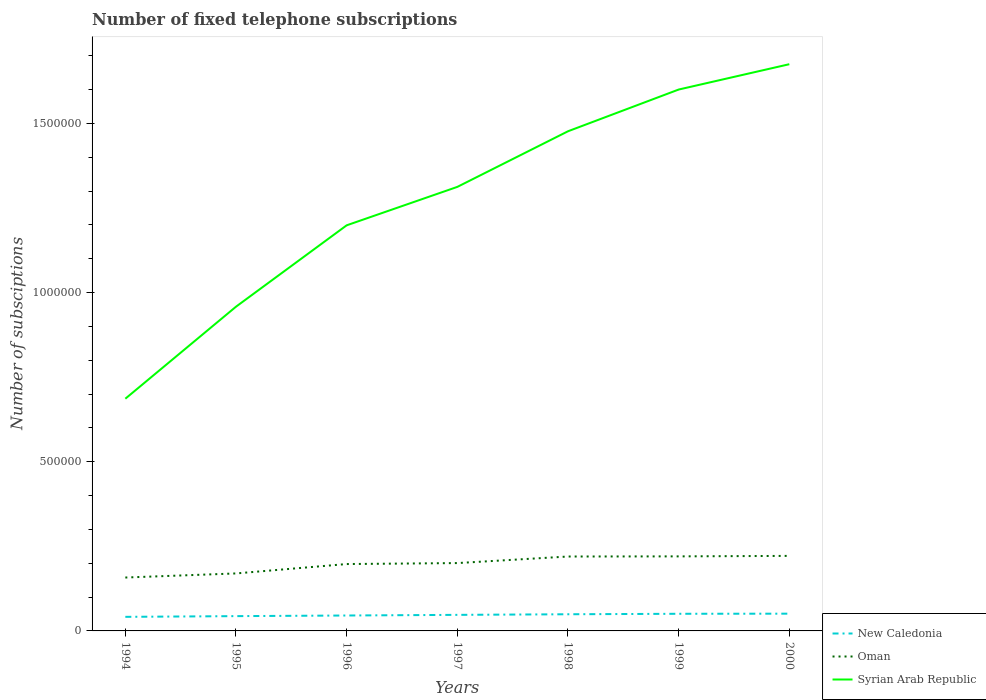How many different coloured lines are there?
Provide a succinct answer. 3. Across all years, what is the maximum number of fixed telephone subscriptions in New Caledonia?
Your answer should be compact. 4.16e+04. In which year was the number of fixed telephone subscriptions in Oman maximum?
Give a very brief answer. 1994. What is the total number of fixed telephone subscriptions in Oman in the graph?
Make the answer very short. -1434. What is the difference between the highest and the second highest number of fixed telephone subscriptions in New Caledonia?
Provide a short and direct response. 9400. Is the number of fixed telephone subscriptions in New Caledonia strictly greater than the number of fixed telephone subscriptions in Syrian Arab Republic over the years?
Provide a succinct answer. Yes. How many lines are there?
Your response must be concise. 3. How many years are there in the graph?
Make the answer very short. 7. What is the difference between two consecutive major ticks on the Y-axis?
Make the answer very short. 5.00e+05. Where does the legend appear in the graph?
Your answer should be very brief. Bottom right. How many legend labels are there?
Your response must be concise. 3. How are the legend labels stacked?
Your response must be concise. Vertical. What is the title of the graph?
Your response must be concise. Number of fixed telephone subscriptions. What is the label or title of the Y-axis?
Provide a short and direct response. Number of subsciptions. What is the Number of subsciptions of New Caledonia in 1994?
Offer a terse response. 4.16e+04. What is the Number of subsciptions of Oman in 1994?
Offer a terse response. 1.58e+05. What is the Number of subsciptions in Syrian Arab Republic in 1994?
Provide a succinct answer. 6.86e+05. What is the Number of subsciptions in New Caledonia in 1995?
Ensure brevity in your answer.  4.37e+04. What is the Number of subsciptions of Oman in 1995?
Your answer should be very brief. 1.70e+05. What is the Number of subsciptions of Syrian Arab Republic in 1995?
Your answer should be compact. 9.58e+05. What is the Number of subsciptions of New Caledonia in 1996?
Your answer should be very brief. 4.56e+04. What is the Number of subsciptions of Oman in 1996?
Your answer should be compact. 1.98e+05. What is the Number of subsciptions of Syrian Arab Republic in 1996?
Keep it short and to the point. 1.20e+06. What is the Number of subsciptions in New Caledonia in 1997?
Give a very brief answer. 4.75e+04. What is the Number of subsciptions in Oman in 1997?
Provide a succinct answer. 2.01e+05. What is the Number of subsciptions in Syrian Arab Republic in 1997?
Ensure brevity in your answer.  1.31e+06. What is the Number of subsciptions of New Caledonia in 1998?
Provide a short and direct response. 4.93e+04. What is the Number of subsciptions in Oman in 1998?
Give a very brief answer. 2.20e+05. What is the Number of subsciptions in Syrian Arab Republic in 1998?
Keep it short and to the point. 1.48e+06. What is the Number of subsciptions in New Caledonia in 1999?
Provide a succinct answer. 5.07e+04. What is the Number of subsciptions in Oman in 1999?
Provide a succinct answer. 2.20e+05. What is the Number of subsciptions of Syrian Arab Republic in 1999?
Make the answer very short. 1.60e+06. What is the Number of subsciptions of New Caledonia in 2000?
Your answer should be very brief. 5.10e+04. What is the Number of subsciptions in Oman in 2000?
Your response must be concise. 2.22e+05. What is the Number of subsciptions in Syrian Arab Republic in 2000?
Provide a short and direct response. 1.68e+06. Across all years, what is the maximum Number of subsciptions of New Caledonia?
Provide a short and direct response. 5.10e+04. Across all years, what is the maximum Number of subsciptions in Oman?
Provide a succinct answer. 2.22e+05. Across all years, what is the maximum Number of subsciptions of Syrian Arab Republic?
Make the answer very short. 1.68e+06. Across all years, what is the minimum Number of subsciptions of New Caledonia?
Offer a terse response. 4.16e+04. Across all years, what is the minimum Number of subsciptions of Oman?
Your answer should be compact. 1.58e+05. Across all years, what is the minimum Number of subsciptions in Syrian Arab Republic?
Give a very brief answer. 6.86e+05. What is the total Number of subsciptions in New Caledonia in the graph?
Give a very brief answer. 3.29e+05. What is the total Number of subsciptions in Oman in the graph?
Offer a terse response. 1.39e+06. What is the total Number of subsciptions in Syrian Arab Republic in the graph?
Provide a succinct answer. 8.91e+06. What is the difference between the Number of subsciptions of New Caledonia in 1994 and that in 1995?
Offer a very short reply. -2120. What is the difference between the Number of subsciptions in Oman in 1994 and that in 1995?
Your response must be concise. -1.21e+04. What is the difference between the Number of subsciptions in Syrian Arab Republic in 1994 and that in 1995?
Provide a succinct answer. -2.72e+05. What is the difference between the Number of subsciptions in New Caledonia in 1994 and that in 1996?
Keep it short and to the point. -3969. What is the difference between the Number of subsciptions of Oman in 1994 and that in 1996?
Offer a very short reply. -3.98e+04. What is the difference between the Number of subsciptions of Syrian Arab Republic in 1994 and that in 1996?
Offer a terse response. -5.13e+05. What is the difference between the Number of subsciptions of New Caledonia in 1994 and that in 1997?
Provide a short and direct response. -5874. What is the difference between the Number of subsciptions in Oman in 1994 and that in 1997?
Give a very brief answer. -4.27e+04. What is the difference between the Number of subsciptions in Syrian Arab Republic in 1994 and that in 1997?
Give a very brief answer. -6.26e+05. What is the difference between the Number of subsciptions of New Caledonia in 1994 and that in 1998?
Your answer should be compact. -7654. What is the difference between the Number of subsciptions in Oman in 1994 and that in 1998?
Offer a very short reply. -6.21e+04. What is the difference between the Number of subsciptions of Syrian Arab Republic in 1994 and that in 1998?
Your answer should be compact. -7.91e+05. What is the difference between the Number of subsciptions in New Caledonia in 1994 and that in 1999?
Your answer should be very brief. -9047. What is the difference between the Number of subsciptions of Oman in 1994 and that in 1999?
Your answer should be very brief. -6.25e+04. What is the difference between the Number of subsciptions of Syrian Arab Republic in 1994 and that in 1999?
Make the answer very short. -9.14e+05. What is the difference between the Number of subsciptions of New Caledonia in 1994 and that in 2000?
Your answer should be compact. -9400. What is the difference between the Number of subsciptions of Oman in 1994 and that in 2000?
Provide a succinct answer. -6.40e+04. What is the difference between the Number of subsciptions in Syrian Arab Republic in 1994 and that in 2000?
Your answer should be compact. -9.89e+05. What is the difference between the Number of subsciptions in New Caledonia in 1995 and that in 1996?
Make the answer very short. -1849. What is the difference between the Number of subsciptions in Oman in 1995 and that in 1996?
Give a very brief answer. -2.77e+04. What is the difference between the Number of subsciptions in Syrian Arab Republic in 1995 and that in 1996?
Keep it short and to the point. -2.41e+05. What is the difference between the Number of subsciptions in New Caledonia in 1995 and that in 1997?
Give a very brief answer. -3754. What is the difference between the Number of subsciptions of Oman in 1995 and that in 1997?
Your response must be concise. -3.06e+04. What is the difference between the Number of subsciptions in Syrian Arab Republic in 1995 and that in 1997?
Offer a very short reply. -3.54e+05. What is the difference between the Number of subsciptions in New Caledonia in 1995 and that in 1998?
Offer a terse response. -5534. What is the difference between the Number of subsciptions of Oman in 1995 and that in 1998?
Keep it short and to the point. -5.00e+04. What is the difference between the Number of subsciptions of Syrian Arab Republic in 1995 and that in 1998?
Give a very brief answer. -5.19e+05. What is the difference between the Number of subsciptions in New Caledonia in 1995 and that in 1999?
Your answer should be very brief. -6927. What is the difference between the Number of subsciptions in Oman in 1995 and that in 1999?
Your answer should be very brief. -5.04e+04. What is the difference between the Number of subsciptions of Syrian Arab Republic in 1995 and that in 1999?
Provide a short and direct response. -6.42e+05. What is the difference between the Number of subsciptions in New Caledonia in 1995 and that in 2000?
Keep it short and to the point. -7280. What is the difference between the Number of subsciptions in Oman in 1995 and that in 2000?
Offer a very short reply. -5.19e+04. What is the difference between the Number of subsciptions of Syrian Arab Republic in 1995 and that in 2000?
Your answer should be very brief. -7.17e+05. What is the difference between the Number of subsciptions in New Caledonia in 1996 and that in 1997?
Ensure brevity in your answer.  -1905. What is the difference between the Number of subsciptions in Oman in 1996 and that in 1997?
Provide a short and direct response. -2870. What is the difference between the Number of subsciptions of Syrian Arab Republic in 1996 and that in 1997?
Your answer should be very brief. -1.14e+05. What is the difference between the Number of subsciptions of New Caledonia in 1996 and that in 1998?
Your answer should be compact. -3685. What is the difference between the Number of subsciptions of Oman in 1996 and that in 1998?
Provide a succinct answer. -2.23e+04. What is the difference between the Number of subsciptions of Syrian Arab Republic in 1996 and that in 1998?
Provide a short and direct response. -2.78e+05. What is the difference between the Number of subsciptions of New Caledonia in 1996 and that in 1999?
Ensure brevity in your answer.  -5078. What is the difference between the Number of subsciptions in Oman in 1996 and that in 1999?
Give a very brief answer. -2.27e+04. What is the difference between the Number of subsciptions of Syrian Arab Republic in 1996 and that in 1999?
Offer a terse response. -4.01e+05. What is the difference between the Number of subsciptions of New Caledonia in 1996 and that in 2000?
Offer a very short reply. -5431. What is the difference between the Number of subsciptions of Oman in 1996 and that in 2000?
Ensure brevity in your answer.  -2.41e+04. What is the difference between the Number of subsciptions in Syrian Arab Republic in 1996 and that in 2000?
Offer a terse response. -4.76e+05. What is the difference between the Number of subsciptions of New Caledonia in 1997 and that in 1998?
Provide a short and direct response. -1780. What is the difference between the Number of subsciptions of Oman in 1997 and that in 1998?
Ensure brevity in your answer.  -1.94e+04. What is the difference between the Number of subsciptions of Syrian Arab Republic in 1997 and that in 1998?
Your answer should be very brief. -1.64e+05. What is the difference between the Number of subsciptions of New Caledonia in 1997 and that in 1999?
Provide a short and direct response. -3173. What is the difference between the Number of subsciptions of Oman in 1997 and that in 1999?
Make the answer very short. -1.98e+04. What is the difference between the Number of subsciptions of Syrian Arab Republic in 1997 and that in 1999?
Your answer should be compact. -2.88e+05. What is the difference between the Number of subsciptions in New Caledonia in 1997 and that in 2000?
Provide a succinct answer. -3526. What is the difference between the Number of subsciptions in Oman in 1997 and that in 2000?
Give a very brief answer. -2.12e+04. What is the difference between the Number of subsciptions of Syrian Arab Republic in 1997 and that in 2000?
Your answer should be compact. -3.63e+05. What is the difference between the Number of subsciptions of New Caledonia in 1998 and that in 1999?
Offer a very short reply. -1393. What is the difference between the Number of subsciptions in Oman in 1998 and that in 1999?
Your answer should be very brief. -417. What is the difference between the Number of subsciptions in Syrian Arab Republic in 1998 and that in 1999?
Your answer should be very brief. -1.23e+05. What is the difference between the Number of subsciptions of New Caledonia in 1998 and that in 2000?
Provide a succinct answer. -1746. What is the difference between the Number of subsciptions of Oman in 1998 and that in 2000?
Give a very brief answer. -1851. What is the difference between the Number of subsciptions in Syrian Arab Republic in 1998 and that in 2000?
Keep it short and to the point. -1.98e+05. What is the difference between the Number of subsciptions of New Caledonia in 1999 and that in 2000?
Your answer should be very brief. -353. What is the difference between the Number of subsciptions of Oman in 1999 and that in 2000?
Offer a terse response. -1434. What is the difference between the Number of subsciptions in Syrian Arab Republic in 1999 and that in 2000?
Your answer should be very brief. -7.49e+04. What is the difference between the Number of subsciptions of New Caledonia in 1994 and the Number of subsciptions of Oman in 1995?
Offer a very short reply. -1.28e+05. What is the difference between the Number of subsciptions in New Caledonia in 1994 and the Number of subsciptions in Syrian Arab Republic in 1995?
Give a very brief answer. -9.17e+05. What is the difference between the Number of subsciptions of Oman in 1994 and the Number of subsciptions of Syrian Arab Republic in 1995?
Give a very brief answer. -8.01e+05. What is the difference between the Number of subsciptions in New Caledonia in 1994 and the Number of subsciptions in Oman in 1996?
Give a very brief answer. -1.56e+05. What is the difference between the Number of subsciptions of New Caledonia in 1994 and the Number of subsciptions of Syrian Arab Republic in 1996?
Ensure brevity in your answer.  -1.16e+06. What is the difference between the Number of subsciptions in Oman in 1994 and the Number of subsciptions in Syrian Arab Republic in 1996?
Provide a succinct answer. -1.04e+06. What is the difference between the Number of subsciptions of New Caledonia in 1994 and the Number of subsciptions of Oman in 1997?
Provide a short and direct response. -1.59e+05. What is the difference between the Number of subsciptions in New Caledonia in 1994 and the Number of subsciptions in Syrian Arab Republic in 1997?
Give a very brief answer. -1.27e+06. What is the difference between the Number of subsciptions of Oman in 1994 and the Number of subsciptions of Syrian Arab Republic in 1997?
Offer a very short reply. -1.15e+06. What is the difference between the Number of subsciptions in New Caledonia in 1994 and the Number of subsciptions in Oman in 1998?
Ensure brevity in your answer.  -1.78e+05. What is the difference between the Number of subsciptions in New Caledonia in 1994 and the Number of subsciptions in Syrian Arab Republic in 1998?
Provide a succinct answer. -1.44e+06. What is the difference between the Number of subsciptions of Oman in 1994 and the Number of subsciptions of Syrian Arab Republic in 1998?
Provide a succinct answer. -1.32e+06. What is the difference between the Number of subsciptions of New Caledonia in 1994 and the Number of subsciptions of Oman in 1999?
Ensure brevity in your answer.  -1.79e+05. What is the difference between the Number of subsciptions in New Caledonia in 1994 and the Number of subsciptions in Syrian Arab Republic in 1999?
Your answer should be compact. -1.56e+06. What is the difference between the Number of subsciptions in Oman in 1994 and the Number of subsciptions in Syrian Arab Republic in 1999?
Give a very brief answer. -1.44e+06. What is the difference between the Number of subsciptions of New Caledonia in 1994 and the Number of subsciptions of Oman in 2000?
Keep it short and to the point. -1.80e+05. What is the difference between the Number of subsciptions in New Caledonia in 1994 and the Number of subsciptions in Syrian Arab Republic in 2000?
Ensure brevity in your answer.  -1.63e+06. What is the difference between the Number of subsciptions in Oman in 1994 and the Number of subsciptions in Syrian Arab Republic in 2000?
Provide a short and direct response. -1.52e+06. What is the difference between the Number of subsciptions in New Caledonia in 1995 and the Number of subsciptions in Oman in 1996?
Your response must be concise. -1.54e+05. What is the difference between the Number of subsciptions of New Caledonia in 1995 and the Number of subsciptions of Syrian Arab Republic in 1996?
Offer a terse response. -1.16e+06. What is the difference between the Number of subsciptions in Oman in 1995 and the Number of subsciptions in Syrian Arab Republic in 1996?
Your answer should be compact. -1.03e+06. What is the difference between the Number of subsciptions in New Caledonia in 1995 and the Number of subsciptions in Oman in 1997?
Offer a very short reply. -1.57e+05. What is the difference between the Number of subsciptions in New Caledonia in 1995 and the Number of subsciptions in Syrian Arab Republic in 1997?
Offer a very short reply. -1.27e+06. What is the difference between the Number of subsciptions in Oman in 1995 and the Number of subsciptions in Syrian Arab Republic in 1997?
Keep it short and to the point. -1.14e+06. What is the difference between the Number of subsciptions in New Caledonia in 1995 and the Number of subsciptions in Oman in 1998?
Provide a short and direct response. -1.76e+05. What is the difference between the Number of subsciptions in New Caledonia in 1995 and the Number of subsciptions in Syrian Arab Republic in 1998?
Your response must be concise. -1.43e+06. What is the difference between the Number of subsciptions in Oman in 1995 and the Number of subsciptions in Syrian Arab Republic in 1998?
Give a very brief answer. -1.31e+06. What is the difference between the Number of subsciptions of New Caledonia in 1995 and the Number of subsciptions of Oman in 1999?
Provide a succinct answer. -1.77e+05. What is the difference between the Number of subsciptions in New Caledonia in 1995 and the Number of subsciptions in Syrian Arab Republic in 1999?
Make the answer very short. -1.56e+06. What is the difference between the Number of subsciptions in Oman in 1995 and the Number of subsciptions in Syrian Arab Republic in 1999?
Ensure brevity in your answer.  -1.43e+06. What is the difference between the Number of subsciptions in New Caledonia in 1995 and the Number of subsciptions in Oman in 2000?
Offer a terse response. -1.78e+05. What is the difference between the Number of subsciptions in New Caledonia in 1995 and the Number of subsciptions in Syrian Arab Republic in 2000?
Provide a short and direct response. -1.63e+06. What is the difference between the Number of subsciptions of Oman in 1995 and the Number of subsciptions of Syrian Arab Republic in 2000?
Ensure brevity in your answer.  -1.51e+06. What is the difference between the Number of subsciptions in New Caledonia in 1996 and the Number of subsciptions in Oman in 1997?
Give a very brief answer. -1.55e+05. What is the difference between the Number of subsciptions of New Caledonia in 1996 and the Number of subsciptions of Syrian Arab Republic in 1997?
Keep it short and to the point. -1.27e+06. What is the difference between the Number of subsciptions of Oman in 1996 and the Number of subsciptions of Syrian Arab Republic in 1997?
Your response must be concise. -1.11e+06. What is the difference between the Number of subsciptions of New Caledonia in 1996 and the Number of subsciptions of Oman in 1998?
Give a very brief answer. -1.74e+05. What is the difference between the Number of subsciptions in New Caledonia in 1996 and the Number of subsciptions in Syrian Arab Republic in 1998?
Ensure brevity in your answer.  -1.43e+06. What is the difference between the Number of subsciptions of Oman in 1996 and the Number of subsciptions of Syrian Arab Republic in 1998?
Provide a succinct answer. -1.28e+06. What is the difference between the Number of subsciptions in New Caledonia in 1996 and the Number of subsciptions in Oman in 1999?
Provide a short and direct response. -1.75e+05. What is the difference between the Number of subsciptions of New Caledonia in 1996 and the Number of subsciptions of Syrian Arab Republic in 1999?
Ensure brevity in your answer.  -1.55e+06. What is the difference between the Number of subsciptions of Oman in 1996 and the Number of subsciptions of Syrian Arab Republic in 1999?
Make the answer very short. -1.40e+06. What is the difference between the Number of subsciptions in New Caledonia in 1996 and the Number of subsciptions in Oman in 2000?
Provide a short and direct response. -1.76e+05. What is the difference between the Number of subsciptions of New Caledonia in 1996 and the Number of subsciptions of Syrian Arab Republic in 2000?
Offer a very short reply. -1.63e+06. What is the difference between the Number of subsciptions in Oman in 1996 and the Number of subsciptions in Syrian Arab Republic in 2000?
Offer a terse response. -1.48e+06. What is the difference between the Number of subsciptions in New Caledonia in 1997 and the Number of subsciptions in Oman in 1998?
Keep it short and to the point. -1.72e+05. What is the difference between the Number of subsciptions of New Caledonia in 1997 and the Number of subsciptions of Syrian Arab Republic in 1998?
Provide a succinct answer. -1.43e+06. What is the difference between the Number of subsciptions in Oman in 1997 and the Number of subsciptions in Syrian Arab Republic in 1998?
Make the answer very short. -1.28e+06. What is the difference between the Number of subsciptions of New Caledonia in 1997 and the Number of subsciptions of Oman in 1999?
Your response must be concise. -1.73e+05. What is the difference between the Number of subsciptions of New Caledonia in 1997 and the Number of subsciptions of Syrian Arab Republic in 1999?
Offer a terse response. -1.55e+06. What is the difference between the Number of subsciptions in Oman in 1997 and the Number of subsciptions in Syrian Arab Republic in 1999?
Keep it short and to the point. -1.40e+06. What is the difference between the Number of subsciptions in New Caledonia in 1997 and the Number of subsciptions in Oman in 2000?
Offer a terse response. -1.74e+05. What is the difference between the Number of subsciptions in New Caledonia in 1997 and the Number of subsciptions in Syrian Arab Republic in 2000?
Provide a short and direct response. -1.63e+06. What is the difference between the Number of subsciptions of Oman in 1997 and the Number of subsciptions of Syrian Arab Republic in 2000?
Your answer should be compact. -1.47e+06. What is the difference between the Number of subsciptions in New Caledonia in 1998 and the Number of subsciptions in Oman in 1999?
Offer a very short reply. -1.71e+05. What is the difference between the Number of subsciptions in New Caledonia in 1998 and the Number of subsciptions in Syrian Arab Republic in 1999?
Your answer should be very brief. -1.55e+06. What is the difference between the Number of subsciptions of Oman in 1998 and the Number of subsciptions of Syrian Arab Republic in 1999?
Provide a succinct answer. -1.38e+06. What is the difference between the Number of subsciptions of New Caledonia in 1998 and the Number of subsciptions of Oman in 2000?
Your answer should be very brief. -1.73e+05. What is the difference between the Number of subsciptions of New Caledonia in 1998 and the Number of subsciptions of Syrian Arab Republic in 2000?
Keep it short and to the point. -1.63e+06. What is the difference between the Number of subsciptions of Oman in 1998 and the Number of subsciptions of Syrian Arab Republic in 2000?
Offer a terse response. -1.46e+06. What is the difference between the Number of subsciptions in New Caledonia in 1999 and the Number of subsciptions in Oman in 2000?
Your response must be concise. -1.71e+05. What is the difference between the Number of subsciptions in New Caledonia in 1999 and the Number of subsciptions in Syrian Arab Republic in 2000?
Keep it short and to the point. -1.62e+06. What is the difference between the Number of subsciptions in Oman in 1999 and the Number of subsciptions in Syrian Arab Republic in 2000?
Your answer should be compact. -1.45e+06. What is the average Number of subsciptions in New Caledonia per year?
Offer a terse response. 4.70e+04. What is the average Number of subsciptions of Oman per year?
Provide a succinct answer. 1.98e+05. What is the average Number of subsciptions of Syrian Arab Republic per year?
Ensure brevity in your answer.  1.27e+06. In the year 1994, what is the difference between the Number of subsciptions in New Caledonia and Number of subsciptions in Oman?
Your answer should be compact. -1.16e+05. In the year 1994, what is the difference between the Number of subsciptions in New Caledonia and Number of subsciptions in Syrian Arab Republic?
Keep it short and to the point. -6.45e+05. In the year 1994, what is the difference between the Number of subsciptions of Oman and Number of subsciptions of Syrian Arab Republic?
Make the answer very short. -5.29e+05. In the year 1995, what is the difference between the Number of subsciptions of New Caledonia and Number of subsciptions of Oman?
Your answer should be compact. -1.26e+05. In the year 1995, what is the difference between the Number of subsciptions of New Caledonia and Number of subsciptions of Syrian Arab Republic?
Offer a terse response. -9.15e+05. In the year 1995, what is the difference between the Number of subsciptions of Oman and Number of subsciptions of Syrian Arab Republic?
Make the answer very short. -7.89e+05. In the year 1996, what is the difference between the Number of subsciptions of New Caledonia and Number of subsciptions of Oman?
Your answer should be compact. -1.52e+05. In the year 1996, what is the difference between the Number of subsciptions of New Caledonia and Number of subsciptions of Syrian Arab Republic?
Provide a succinct answer. -1.15e+06. In the year 1996, what is the difference between the Number of subsciptions of Oman and Number of subsciptions of Syrian Arab Republic?
Your answer should be compact. -1.00e+06. In the year 1997, what is the difference between the Number of subsciptions of New Caledonia and Number of subsciptions of Oman?
Provide a short and direct response. -1.53e+05. In the year 1997, what is the difference between the Number of subsciptions in New Caledonia and Number of subsciptions in Syrian Arab Republic?
Make the answer very short. -1.27e+06. In the year 1997, what is the difference between the Number of subsciptions in Oman and Number of subsciptions in Syrian Arab Republic?
Your response must be concise. -1.11e+06. In the year 1998, what is the difference between the Number of subsciptions of New Caledonia and Number of subsciptions of Oman?
Make the answer very short. -1.71e+05. In the year 1998, what is the difference between the Number of subsciptions of New Caledonia and Number of subsciptions of Syrian Arab Republic?
Keep it short and to the point. -1.43e+06. In the year 1998, what is the difference between the Number of subsciptions in Oman and Number of subsciptions in Syrian Arab Republic?
Keep it short and to the point. -1.26e+06. In the year 1999, what is the difference between the Number of subsciptions in New Caledonia and Number of subsciptions in Oman?
Provide a succinct answer. -1.70e+05. In the year 1999, what is the difference between the Number of subsciptions of New Caledonia and Number of subsciptions of Syrian Arab Republic?
Make the answer very short. -1.55e+06. In the year 1999, what is the difference between the Number of subsciptions in Oman and Number of subsciptions in Syrian Arab Republic?
Provide a short and direct response. -1.38e+06. In the year 2000, what is the difference between the Number of subsciptions of New Caledonia and Number of subsciptions of Oman?
Your answer should be compact. -1.71e+05. In the year 2000, what is the difference between the Number of subsciptions in New Caledonia and Number of subsciptions in Syrian Arab Republic?
Your response must be concise. -1.62e+06. In the year 2000, what is the difference between the Number of subsciptions of Oman and Number of subsciptions of Syrian Arab Republic?
Keep it short and to the point. -1.45e+06. What is the ratio of the Number of subsciptions in New Caledonia in 1994 to that in 1995?
Provide a succinct answer. 0.95. What is the ratio of the Number of subsciptions in Oman in 1994 to that in 1995?
Provide a succinct answer. 0.93. What is the ratio of the Number of subsciptions in Syrian Arab Republic in 1994 to that in 1995?
Give a very brief answer. 0.72. What is the ratio of the Number of subsciptions in New Caledonia in 1994 to that in 1996?
Your answer should be compact. 0.91. What is the ratio of the Number of subsciptions in Oman in 1994 to that in 1996?
Provide a short and direct response. 0.8. What is the ratio of the Number of subsciptions in Syrian Arab Republic in 1994 to that in 1996?
Keep it short and to the point. 0.57. What is the ratio of the Number of subsciptions of New Caledonia in 1994 to that in 1997?
Your response must be concise. 0.88. What is the ratio of the Number of subsciptions in Oman in 1994 to that in 1997?
Keep it short and to the point. 0.79. What is the ratio of the Number of subsciptions of Syrian Arab Republic in 1994 to that in 1997?
Your answer should be compact. 0.52. What is the ratio of the Number of subsciptions of New Caledonia in 1994 to that in 1998?
Provide a short and direct response. 0.84. What is the ratio of the Number of subsciptions in Oman in 1994 to that in 1998?
Give a very brief answer. 0.72. What is the ratio of the Number of subsciptions of Syrian Arab Republic in 1994 to that in 1998?
Offer a very short reply. 0.46. What is the ratio of the Number of subsciptions in New Caledonia in 1994 to that in 1999?
Your response must be concise. 0.82. What is the ratio of the Number of subsciptions of Oman in 1994 to that in 1999?
Keep it short and to the point. 0.72. What is the ratio of the Number of subsciptions of Syrian Arab Republic in 1994 to that in 1999?
Your answer should be very brief. 0.43. What is the ratio of the Number of subsciptions of New Caledonia in 1994 to that in 2000?
Your response must be concise. 0.82. What is the ratio of the Number of subsciptions of Oman in 1994 to that in 2000?
Provide a succinct answer. 0.71. What is the ratio of the Number of subsciptions of Syrian Arab Republic in 1994 to that in 2000?
Make the answer very short. 0.41. What is the ratio of the Number of subsciptions in New Caledonia in 1995 to that in 1996?
Provide a short and direct response. 0.96. What is the ratio of the Number of subsciptions in Oman in 1995 to that in 1996?
Keep it short and to the point. 0.86. What is the ratio of the Number of subsciptions of Syrian Arab Republic in 1995 to that in 1996?
Offer a very short reply. 0.8. What is the ratio of the Number of subsciptions of New Caledonia in 1995 to that in 1997?
Your answer should be compact. 0.92. What is the ratio of the Number of subsciptions of Oman in 1995 to that in 1997?
Your answer should be very brief. 0.85. What is the ratio of the Number of subsciptions in Syrian Arab Republic in 1995 to that in 1997?
Offer a terse response. 0.73. What is the ratio of the Number of subsciptions in New Caledonia in 1995 to that in 1998?
Ensure brevity in your answer.  0.89. What is the ratio of the Number of subsciptions of Oman in 1995 to that in 1998?
Your answer should be compact. 0.77. What is the ratio of the Number of subsciptions of Syrian Arab Republic in 1995 to that in 1998?
Offer a terse response. 0.65. What is the ratio of the Number of subsciptions in New Caledonia in 1995 to that in 1999?
Keep it short and to the point. 0.86. What is the ratio of the Number of subsciptions in Oman in 1995 to that in 1999?
Your answer should be compact. 0.77. What is the ratio of the Number of subsciptions in Syrian Arab Republic in 1995 to that in 1999?
Provide a short and direct response. 0.6. What is the ratio of the Number of subsciptions in New Caledonia in 1995 to that in 2000?
Offer a very short reply. 0.86. What is the ratio of the Number of subsciptions in Oman in 1995 to that in 2000?
Keep it short and to the point. 0.77. What is the ratio of the Number of subsciptions of Syrian Arab Republic in 1995 to that in 2000?
Make the answer very short. 0.57. What is the ratio of the Number of subsciptions of New Caledonia in 1996 to that in 1997?
Keep it short and to the point. 0.96. What is the ratio of the Number of subsciptions of Oman in 1996 to that in 1997?
Your response must be concise. 0.99. What is the ratio of the Number of subsciptions in Syrian Arab Republic in 1996 to that in 1997?
Provide a succinct answer. 0.91. What is the ratio of the Number of subsciptions in New Caledonia in 1996 to that in 1998?
Your response must be concise. 0.93. What is the ratio of the Number of subsciptions in Oman in 1996 to that in 1998?
Offer a terse response. 0.9. What is the ratio of the Number of subsciptions in Syrian Arab Republic in 1996 to that in 1998?
Your answer should be compact. 0.81. What is the ratio of the Number of subsciptions in New Caledonia in 1996 to that in 1999?
Make the answer very short. 0.9. What is the ratio of the Number of subsciptions in Oman in 1996 to that in 1999?
Give a very brief answer. 0.9. What is the ratio of the Number of subsciptions in Syrian Arab Republic in 1996 to that in 1999?
Give a very brief answer. 0.75. What is the ratio of the Number of subsciptions of New Caledonia in 1996 to that in 2000?
Ensure brevity in your answer.  0.89. What is the ratio of the Number of subsciptions of Oman in 1996 to that in 2000?
Your answer should be compact. 0.89. What is the ratio of the Number of subsciptions of Syrian Arab Republic in 1996 to that in 2000?
Your answer should be compact. 0.72. What is the ratio of the Number of subsciptions of New Caledonia in 1997 to that in 1998?
Your response must be concise. 0.96. What is the ratio of the Number of subsciptions of Oman in 1997 to that in 1998?
Ensure brevity in your answer.  0.91. What is the ratio of the Number of subsciptions of Syrian Arab Republic in 1997 to that in 1998?
Your answer should be very brief. 0.89. What is the ratio of the Number of subsciptions of New Caledonia in 1997 to that in 1999?
Make the answer very short. 0.94. What is the ratio of the Number of subsciptions in Oman in 1997 to that in 1999?
Provide a short and direct response. 0.91. What is the ratio of the Number of subsciptions of Syrian Arab Republic in 1997 to that in 1999?
Offer a terse response. 0.82. What is the ratio of the Number of subsciptions of New Caledonia in 1997 to that in 2000?
Give a very brief answer. 0.93. What is the ratio of the Number of subsciptions of Oman in 1997 to that in 2000?
Offer a very short reply. 0.9. What is the ratio of the Number of subsciptions in Syrian Arab Republic in 1997 to that in 2000?
Offer a terse response. 0.78. What is the ratio of the Number of subsciptions of New Caledonia in 1998 to that in 1999?
Provide a succinct answer. 0.97. What is the ratio of the Number of subsciptions of Oman in 1998 to that in 1999?
Ensure brevity in your answer.  1. What is the ratio of the Number of subsciptions in Syrian Arab Republic in 1998 to that in 1999?
Keep it short and to the point. 0.92. What is the ratio of the Number of subsciptions of New Caledonia in 1998 to that in 2000?
Provide a short and direct response. 0.97. What is the ratio of the Number of subsciptions in Oman in 1998 to that in 2000?
Offer a terse response. 0.99. What is the ratio of the Number of subsciptions in Syrian Arab Republic in 1998 to that in 2000?
Keep it short and to the point. 0.88. What is the ratio of the Number of subsciptions in Syrian Arab Republic in 1999 to that in 2000?
Make the answer very short. 0.96. What is the difference between the highest and the second highest Number of subsciptions in New Caledonia?
Your answer should be compact. 353. What is the difference between the highest and the second highest Number of subsciptions of Oman?
Your response must be concise. 1434. What is the difference between the highest and the second highest Number of subsciptions of Syrian Arab Republic?
Offer a terse response. 7.49e+04. What is the difference between the highest and the lowest Number of subsciptions of New Caledonia?
Offer a terse response. 9400. What is the difference between the highest and the lowest Number of subsciptions of Oman?
Ensure brevity in your answer.  6.40e+04. What is the difference between the highest and the lowest Number of subsciptions of Syrian Arab Republic?
Keep it short and to the point. 9.89e+05. 